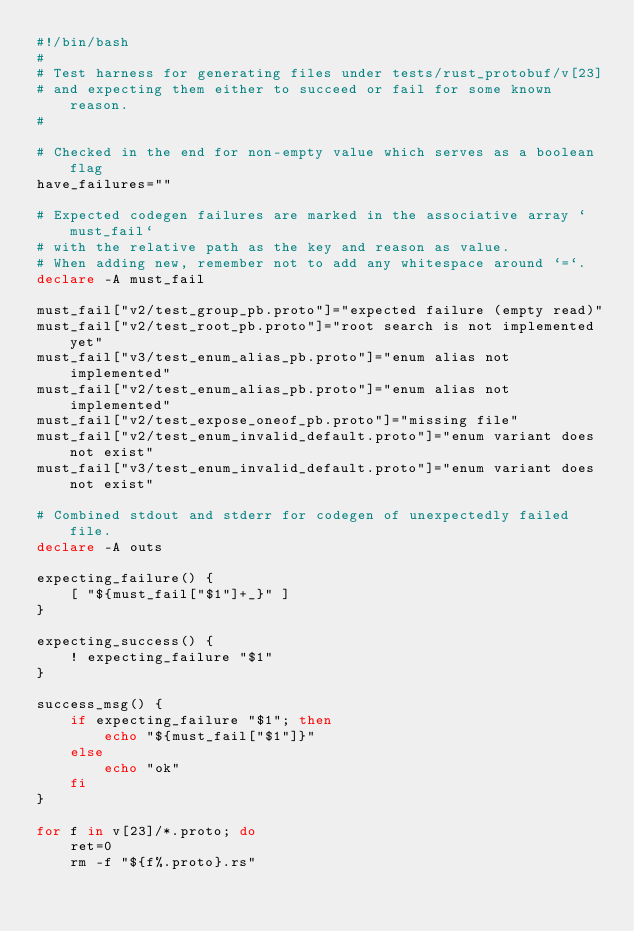<code> <loc_0><loc_0><loc_500><loc_500><_Bash_>#!/bin/bash
#
# Test harness for generating files under tests/rust_protobuf/v[23]
# and expecting them either to succeed or fail for some known reason.
#

# Checked in the end for non-empty value which serves as a boolean flag
have_failures=""

# Expected codegen failures are marked in the associative array `must_fail`
# with the relative path as the key and reason as value.
# When adding new, remember not to add any whitespace around `=`.
declare -A must_fail

must_fail["v2/test_group_pb.proto"]="expected failure (empty read)"
must_fail["v2/test_root_pb.proto"]="root search is not implemented yet"
must_fail["v3/test_enum_alias_pb.proto"]="enum alias not implemented"
must_fail["v2/test_enum_alias_pb.proto"]="enum alias not implemented"
must_fail["v2/test_expose_oneof_pb.proto"]="missing file"
must_fail["v2/test_enum_invalid_default.proto"]="enum variant does not exist"
must_fail["v3/test_enum_invalid_default.proto"]="enum variant does not exist"

# Combined stdout and stderr for codegen of unexpectedly failed file.
declare -A outs

expecting_failure() {
	[ "${must_fail["$1"]+_}" ]
}

expecting_success() {
	! expecting_failure "$1"
}

success_msg() {
	if expecting_failure "$1"; then
		echo "${must_fail["$1"]}"
	else
		echo "ok"
	fi
}

for f in v[23]/*.proto; do
	ret=0
	rm -f "${f%.proto}.rs"</code> 